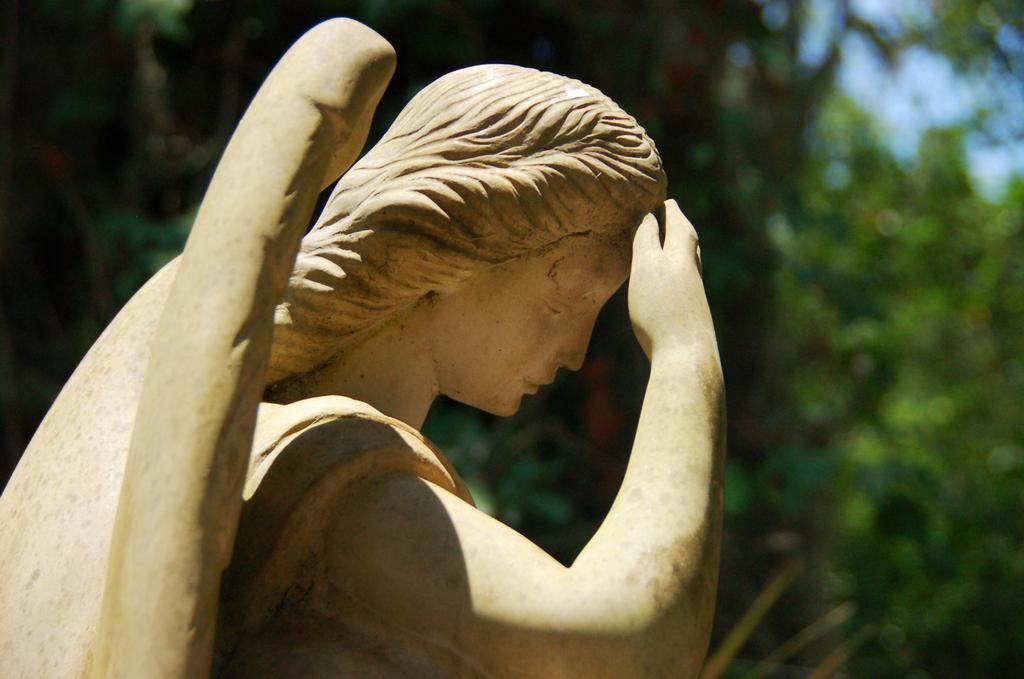What is the main subject of the image? There is a statue of a person in the image. What color is the statue? The statue is cream in color. What can be seen in the background of the image? There are trees and the sky visible in the background of the image. What color are the trees? The trees are green in color. What color is the sky? The sky is blue in color. What type of vegetable is growing on the statue's head in the image? There are no vegetables present in the image, and the statue's head does not have any vegetable growth. Can you see an owl perched on the statue in the image? There is no owl present in the image; the statue is the main subject. 